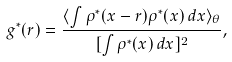Convert formula to latex. <formula><loc_0><loc_0><loc_500><loc_500>g ^ { * } ( r ) = \frac { \langle \int \rho ^ { * } ( { x } - { r } ) \rho ^ { * } ( { x } ) \, d { x } \rangle _ { \theta } } { [ \int \rho ^ { * } ( { x } ) \, d { x } ] ^ { 2 } } ,</formula> 